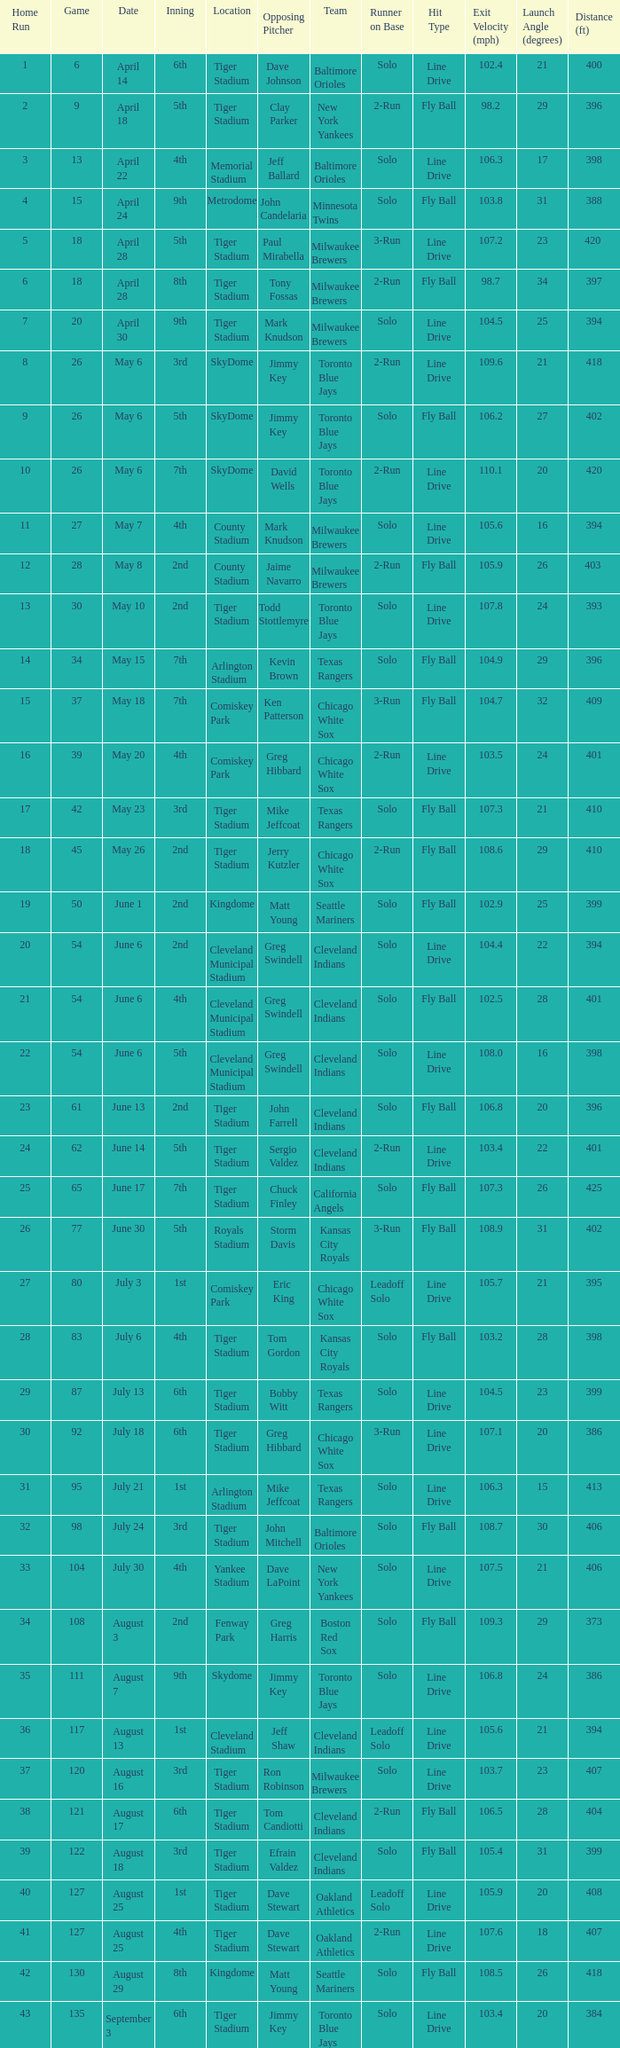What date was the game at Comiskey Park and had a 4th Inning? May 20. 